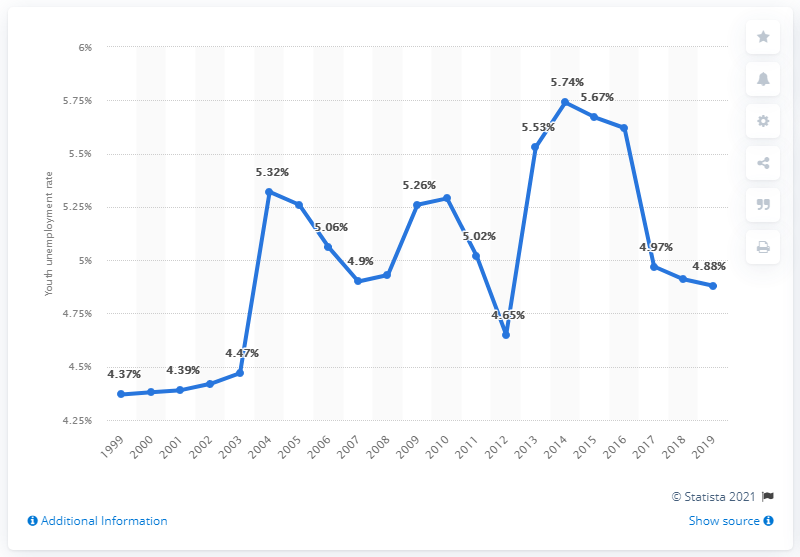What was the youth unemployment rate in Guatemala in 2019? In 2019, the youth unemployment rate in Guatemala was recorded at 4.88%, as shown in the provided chart. This figure represents a slight decrease from the previous year's rate of 4.97%. 